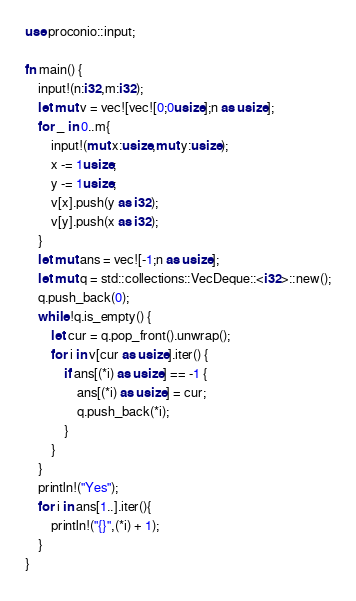Convert code to text. <code><loc_0><loc_0><loc_500><loc_500><_Rust_>use proconio::input;

fn main() {
    input!(n:i32,m:i32);
    let mut v = vec![vec![0;0usize];n as usize];
    for _ in 0..m{
        input!(mut x:usize,mut y:usize);
        x -= 1usize;
        y -= 1usize;
        v[x].push(y as i32);
        v[y].push(x as i32);
    }
    let mut ans = vec![-1;n as usize];
    let mut q = std::collections::VecDeque::<i32>::new();
    q.push_back(0);
    while !q.is_empty() {
        let cur = q.pop_front().unwrap();
        for i in v[cur as usize].iter() {
            if ans[(*i) as usize] == -1 {
                ans[(*i) as usize] = cur;
                q.push_back(*i);
            }
        } 
    }
    println!("Yes");
    for i in ans[1..].iter(){
        println!("{}",(*i) + 1);
    }
}
</code> 